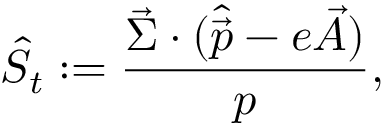Convert formula to latex. <formula><loc_0><loc_0><loc_500><loc_500>\hat { S } _ { t } \colon = { \frac { \vec { \Sigma } \cdot ( \hat { \vec { p } } - e \vec { A } ) } { p } } ,</formula> 